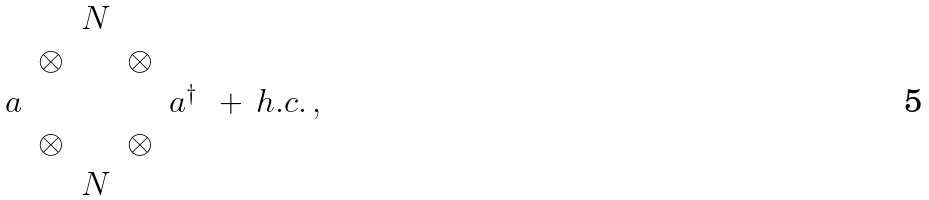<formula> <loc_0><loc_0><loc_500><loc_500>\begin{array} { c c c c c } & & N & & \\ & \otimes & & \otimes & \\ a & & & & a ^ { \dagger } \\ & \otimes & & \otimes & \\ & & N & & \end{array} \, + \, h . c . \, ,</formula> 